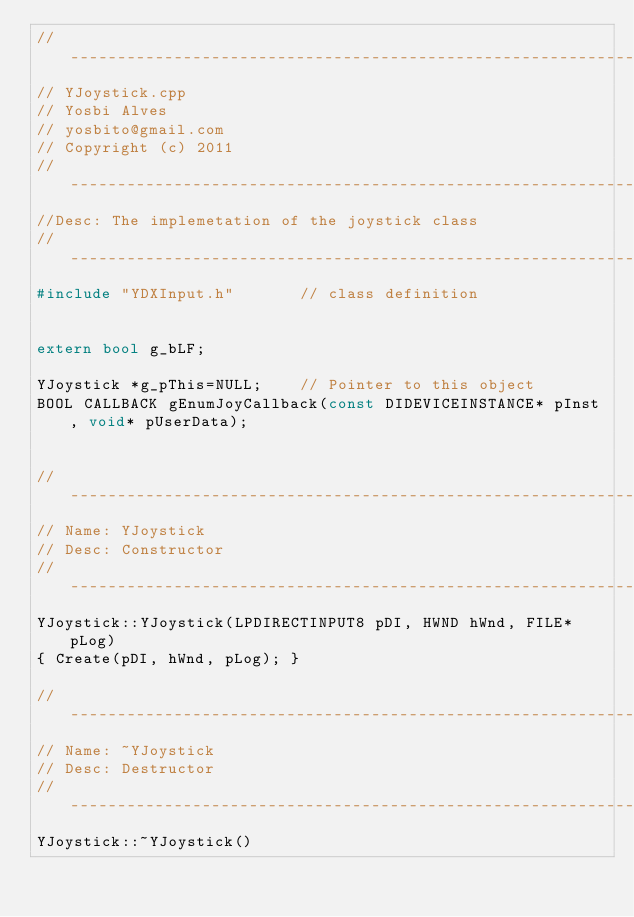Convert code to text. <code><loc_0><loc_0><loc_500><loc_500><_C++_>//-------------------------------------------------------------------------------
// YJoystick.cpp
// Yosbi Alves
// yosbito@gmail.com
// Copyright (c) 2011
//-----------------------------------------------------------------------
//Desc: The implemetation of the joystick class
//--------------------------------------------------------------------------
#include "YDXInput.h"		// class definition


extern bool g_bLF;

YJoystick *g_pThis=NULL;	// Pointer to this object
BOOL CALLBACK gEnumJoyCallback(const DIDEVICEINSTANCE* pInst, void* pUserData);


//-----------------------------------------------------------------------
// Name: YJoystick
// Desc: Constructor
//-----------------------------------------------------------------------
YJoystick::YJoystick(LPDIRECTINPUT8 pDI, HWND hWnd, FILE* pLog) 
{ Create(pDI, hWnd, pLog); }

//-----------------------------------------------------------------------
// Name: ~YJoystick
// Desc: Destructor
//-----------------------------------------------------------------------
YJoystick::~YJoystick() </code> 